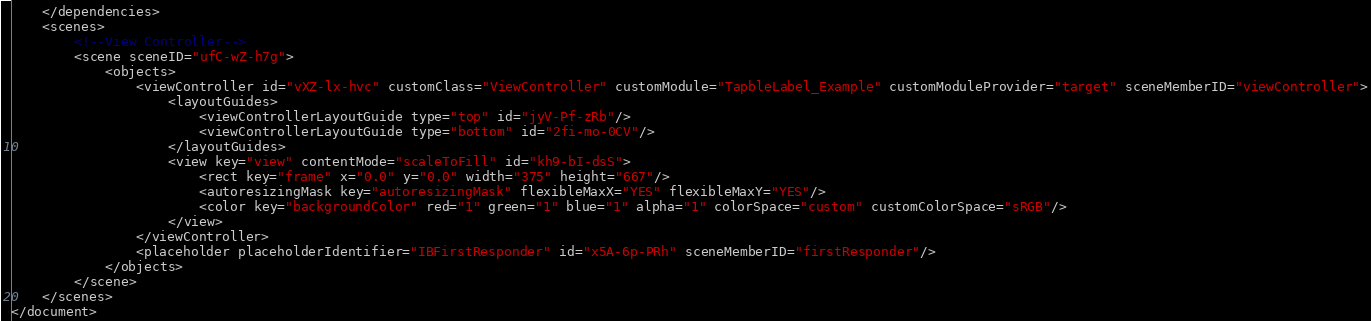Convert code to text. <code><loc_0><loc_0><loc_500><loc_500><_XML_>    </dependencies>
    <scenes>
        <!--View Controller-->
        <scene sceneID="ufC-wZ-h7g">
            <objects>
                <viewController id="vXZ-lx-hvc" customClass="ViewController" customModule="TapbleLabel_Example" customModuleProvider="target" sceneMemberID="viewController">
                    <layoutGuides>
                        <viewControllerLayoutGuide type="top" id="jyV-Pf-zRb"/>
                        <viewControllerLayoutGuide type="bottom" id="2fi-mo-0CV"/>
                    </layoutGuides>
                    <view key="view" contentMode="scaleToFill" id="kh9-bI-dsS">
                        <rect key="frame" x="0.0" y="0.0" width="375" height="667"/>
                        <autoresizingMask key="autoresizingMask" flexibleMaxX="YES" flexibleMaxY="YES"/>
                        <color key="backgroundColor" red="1" green="1" blue="1" alpha="1" colorSpace="custom" customColorSpace="sRGB"/>
                    </view>
                </viewController>
                <placeholder placeholderIdentifier="IBFirstResponder" id="x5A-6p-PRh" sceneMemberID="firstResponder"/>
            </objects>
        </scene>
    </scenes>
</document>
</code> 